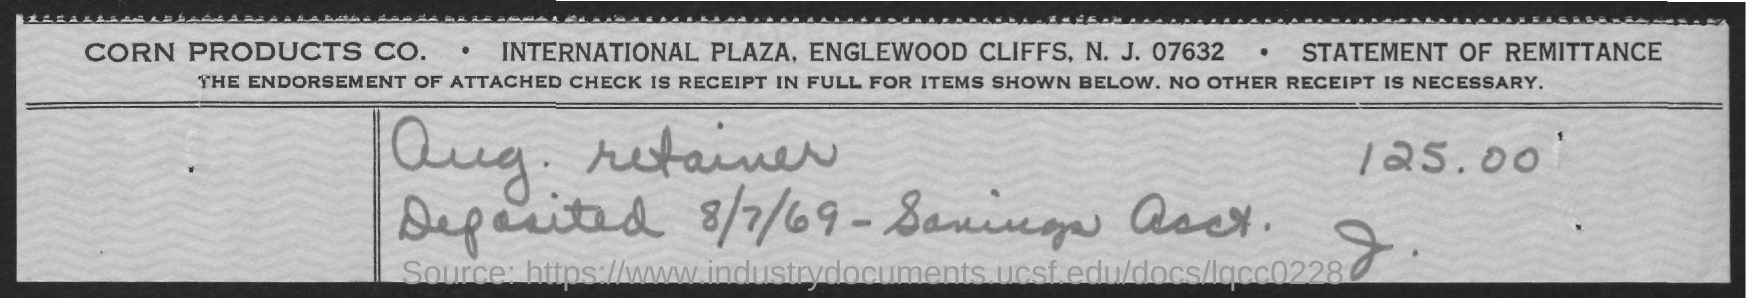What type of statment is it?
Give a very brief answer. Statement of remittance. What is the deposited date?
Provide a short and direct response. 8/7/69. What is the amount mentioned?
Provide a succinct answer. 125.00. 